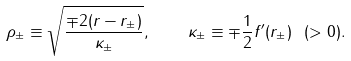<formula> <loc_0><loc_0><loc_500><loc_500>\rho _ { \pm } \equiv \sqrt { \frac { \mp 2 ( r - r _ { \pm } ) } { \kappa _ { \pm } } } , \quad \kappa _ { \pm } \equiv \mp \frac { 1 } { 2 } f ^ { \prime } ( r _ { \pm } ) \ ( > 0 ) .</formula> 